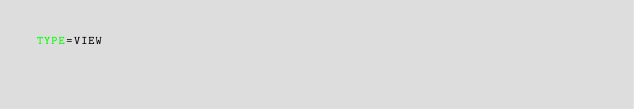Convert code to text. <code><loc_0><loc_0><loc_500><loc_500><_VisualBasic_>TYPE=VIEW</code> 